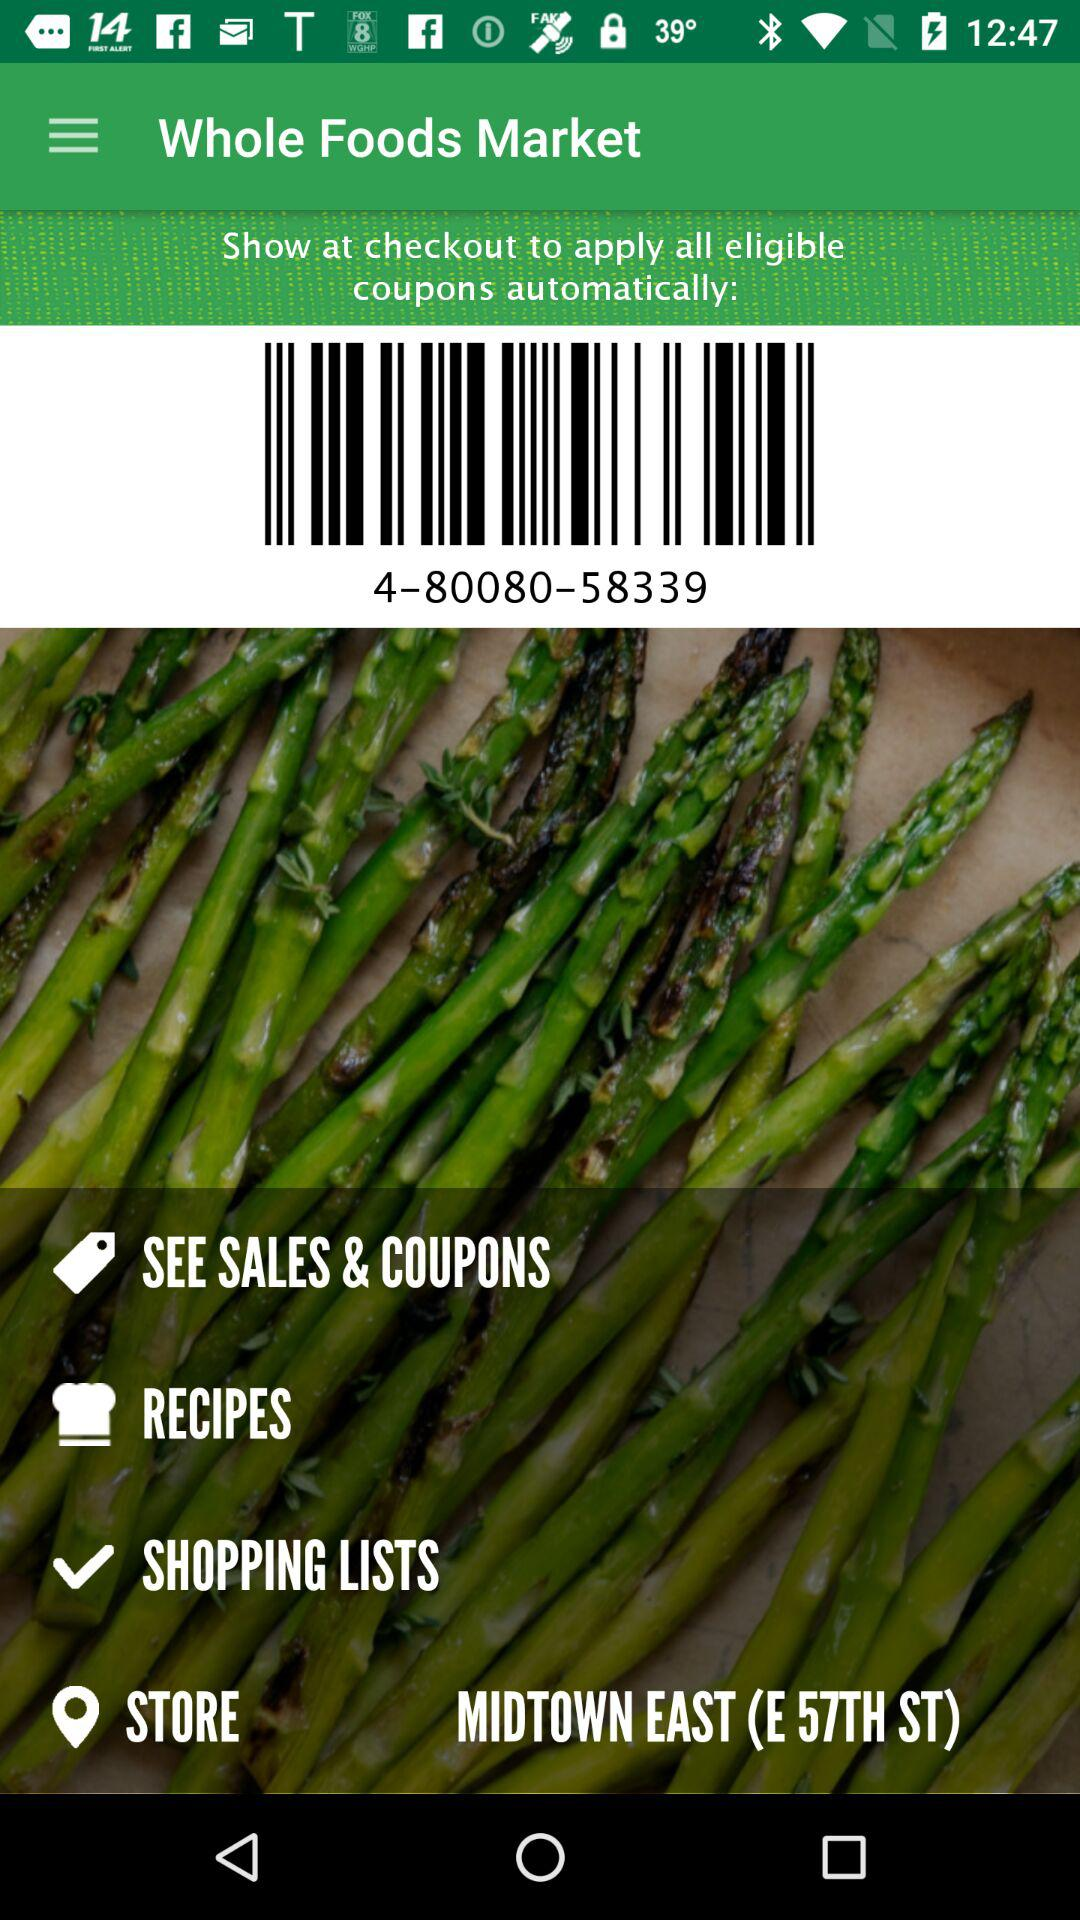What is the application name? The application name is "Whole Foods Market". 